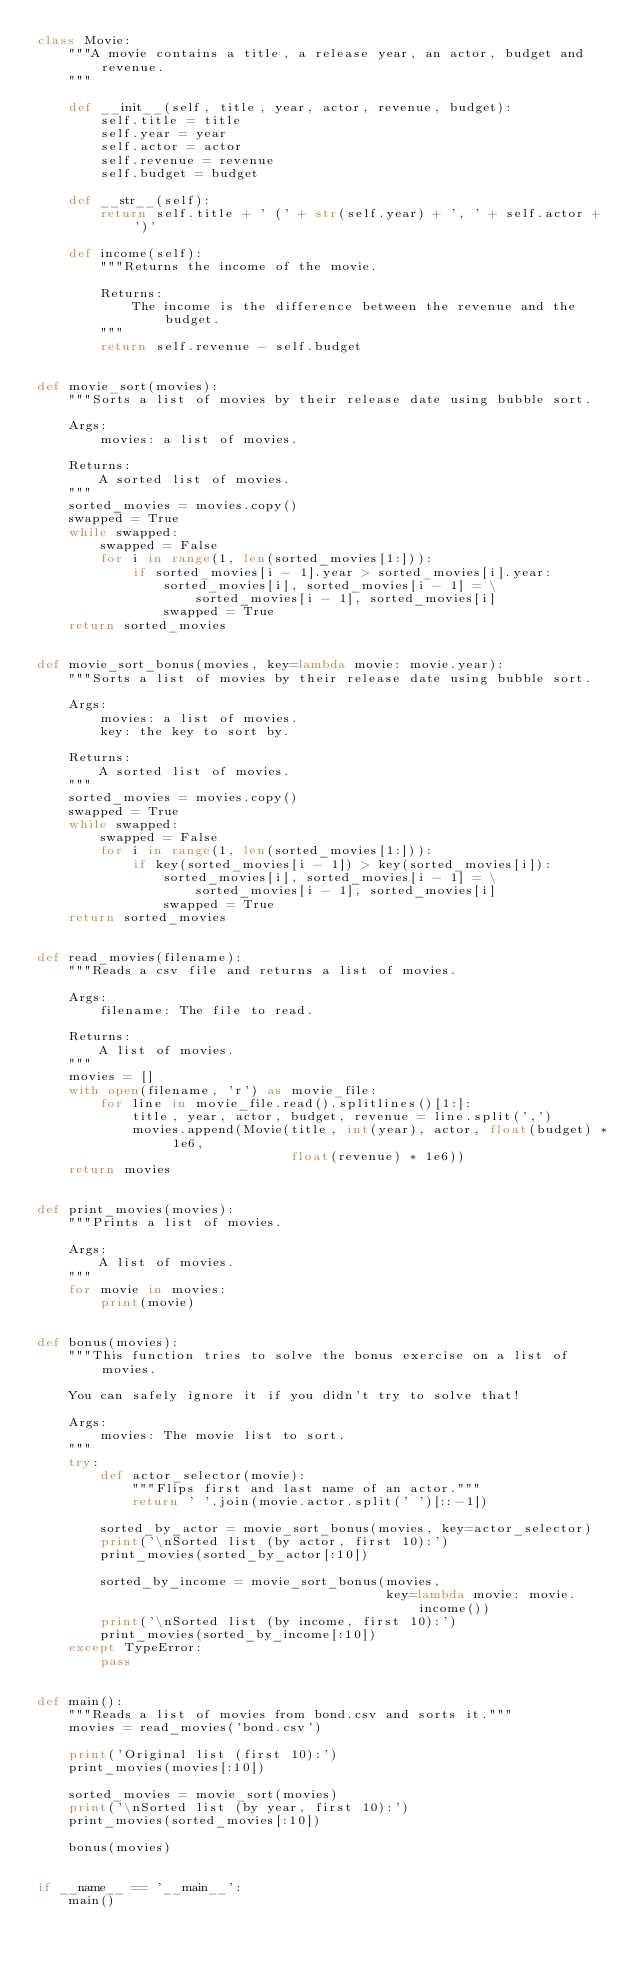<code> <loc_0><loc_0><loc_500><loc_500><_Python_>class Movie:
    """A movie contains a title, a release year, an actor, budget and revenue.
    """

    def __init__(self, title, year, actor, revenue, budget):
        self.title = title
        self.year = year
        self.actor = actor
        self.revenue = revenue
        self.budget = budget

    def __str__(self):
        return self.title + ' (' + str(self.year) + ', ' + self.actor + ')'

    def income(self):
        """Returns the income of the movie.

        Returns:
            The income is the difference between the revenue and the budget.
        """
        return self.revenue - self.budget


def movie_sort(movies):
    """Sorts a list of movies by their release date using bubble sort.

    Args:
        movies: a list of movies.

    Returns:
        A sorted list of movies.
    """
    sorted_movies = movies.copy()
    swapped = True
    while swapped:
        swapped = False
        for i in range(1, len(sorted_movies[1:])):
            if sorted_movies[i - 1].year > sorted_movies[i].year:
                sorted_movies[i], sorted_movies[i - 1] = \
                    sorted_movies[i - 1], sorted_movies[i]
                swapped = True
    return sorted_movies


def movie_sort_bonus(movies, key=lambda movie: movie.year):
    """Sorts a list of movies by their release date using bubble sort.

    Args:
        movies: a list of movies.
        key: the key to sort by.

    Returns:
        A sorted list of movies.
    """
    sorted_movies = movies.copy()
    swapped = True
    while swapped:
        swapped = False
        for i in range(1, len(sorted_movies[1:])):
            if key(sorted_movies[i - 1]) > key(sorted_movies[i]):
                sorted_movies[i], sorted_movies[i - 1] = \
                    sorted_movies[i - 1], sorted_movies[i]
                swapped = True
    return sorted_movies


def read_movies(filename):
    """Reads a csv file and returns a list of movies.

    Args:
        filename: The file to read.

    Returns:
        A list of movies.
    """
    movies = []
    with open(filename, 'r') as movie_file:
        for line in movie_file.read().splitlines()[1:]:
            title, year, actor, budget, revenue = line.split(',')
            movies.append(Movie(title, int(year), actor, float(budget) * 1e6,
                                float(revenue) * 1e6))
    return movies


def print_movies(movies):
    """Prints a list of movies.

    Args:
        A list of movies.
    """
    for movie in movies:
        print(movie)


def bonus(movies):
    """This function tries to solve the bonus exercise on a list of movies.

    You can safely ignore it if you didn't try to solve that!

    Args:
        movies: The movie list to sort.
    """
    try:
        def actor_selector(movie):
            """Flips first and last name of an actor."""
            return ' '.join(movie.actor.split(' ')[::-1])

        sorted_by_actor = movie_sort_bonus(movies, key=actor_selector)
        print('\nSorted list (by actor, first 10):')
        print_movies(sorted_by_actor[:10])

        sorted_by_income = movie_sort_bonus(movies,
                                            key=lambda movie: movie.income())
        print('\nSorted list (by income, first 10):')
        print_movies(sorted_by_income[:10])
    except TypeError:
        pass


def main():
    """Reads a list of movies from bond.csv and sorts it."""
    movies = read_movies('bond.csv')

    print('Original list (first 10):')
    print_movies(movies[:10])

    sorted_movies = movie_sort(movies)
    print('\nSorted list (by year, first 10):')
    print_movies(sorted_movies[:10])

    bonus(movies)


if __name__ == '__main__':
    main()
</code> 